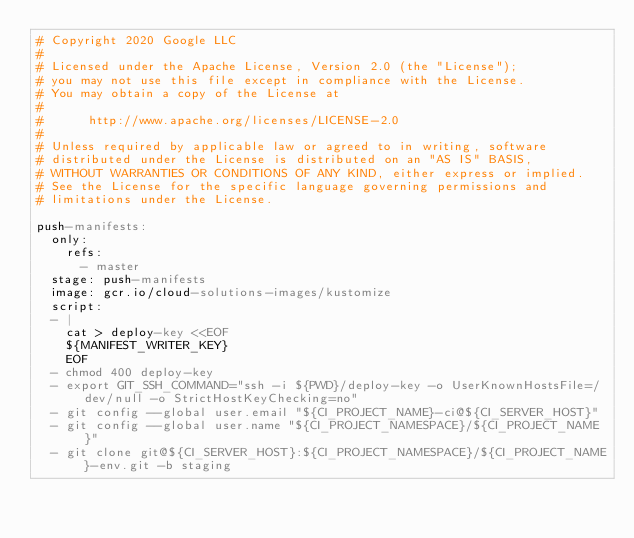<code> <loc_0><loc_0><loc_500><loc_500><_YAML_># Copyright 2020 Google LLC
#
# Licensed under the Apache License, Version 2.0 (the "License");
# you may not use this file except in compliance with the License.
# You may obtain a copy of the License at
#
#      http://www.apache.org/licenses/LICENSE-2.0
#
# Unless required by applicable law or agreed to in writing, software
# distributed under the License is distributed on an "AS IS" BASIS,
# WITHOUT WARRANTIES OR CONDITIONS OF ANY KIND, either express or implied.
# See the License for the specific language governing permissions and
# limitations under the License.

push-manifests:
  only:
    refs:
      - master
  stage: push-manifests
  image: gcr.io/cloud-solutions-images/kustomize
  script:
  - |
    cat > deploy-key <<EOF
    ${MANIFEST_WRITER_KEY}
    EOF
  - chmod 400 deploy-key
  - export GIT_SSH_COMMAND="ssh -i ${PWD}/deploy-key -o UserKnownHostsFile=/dev/null -o StrictHostKeyChecking=no"
  - git config --global user.email "${CI_PROJECT_NAME}-ci@${CI_SERVER_HOST}"
  - git config --global user.name "${CI_PROJECT_NAMESPACE}/${CI_PROJECT_NAME}"
  - git clone git@${CI_SERVER_HOST}:${CI_PROJECT_NAMESPACE}/${CI_PROJECT_NAME}-env.git -b staging</code> 